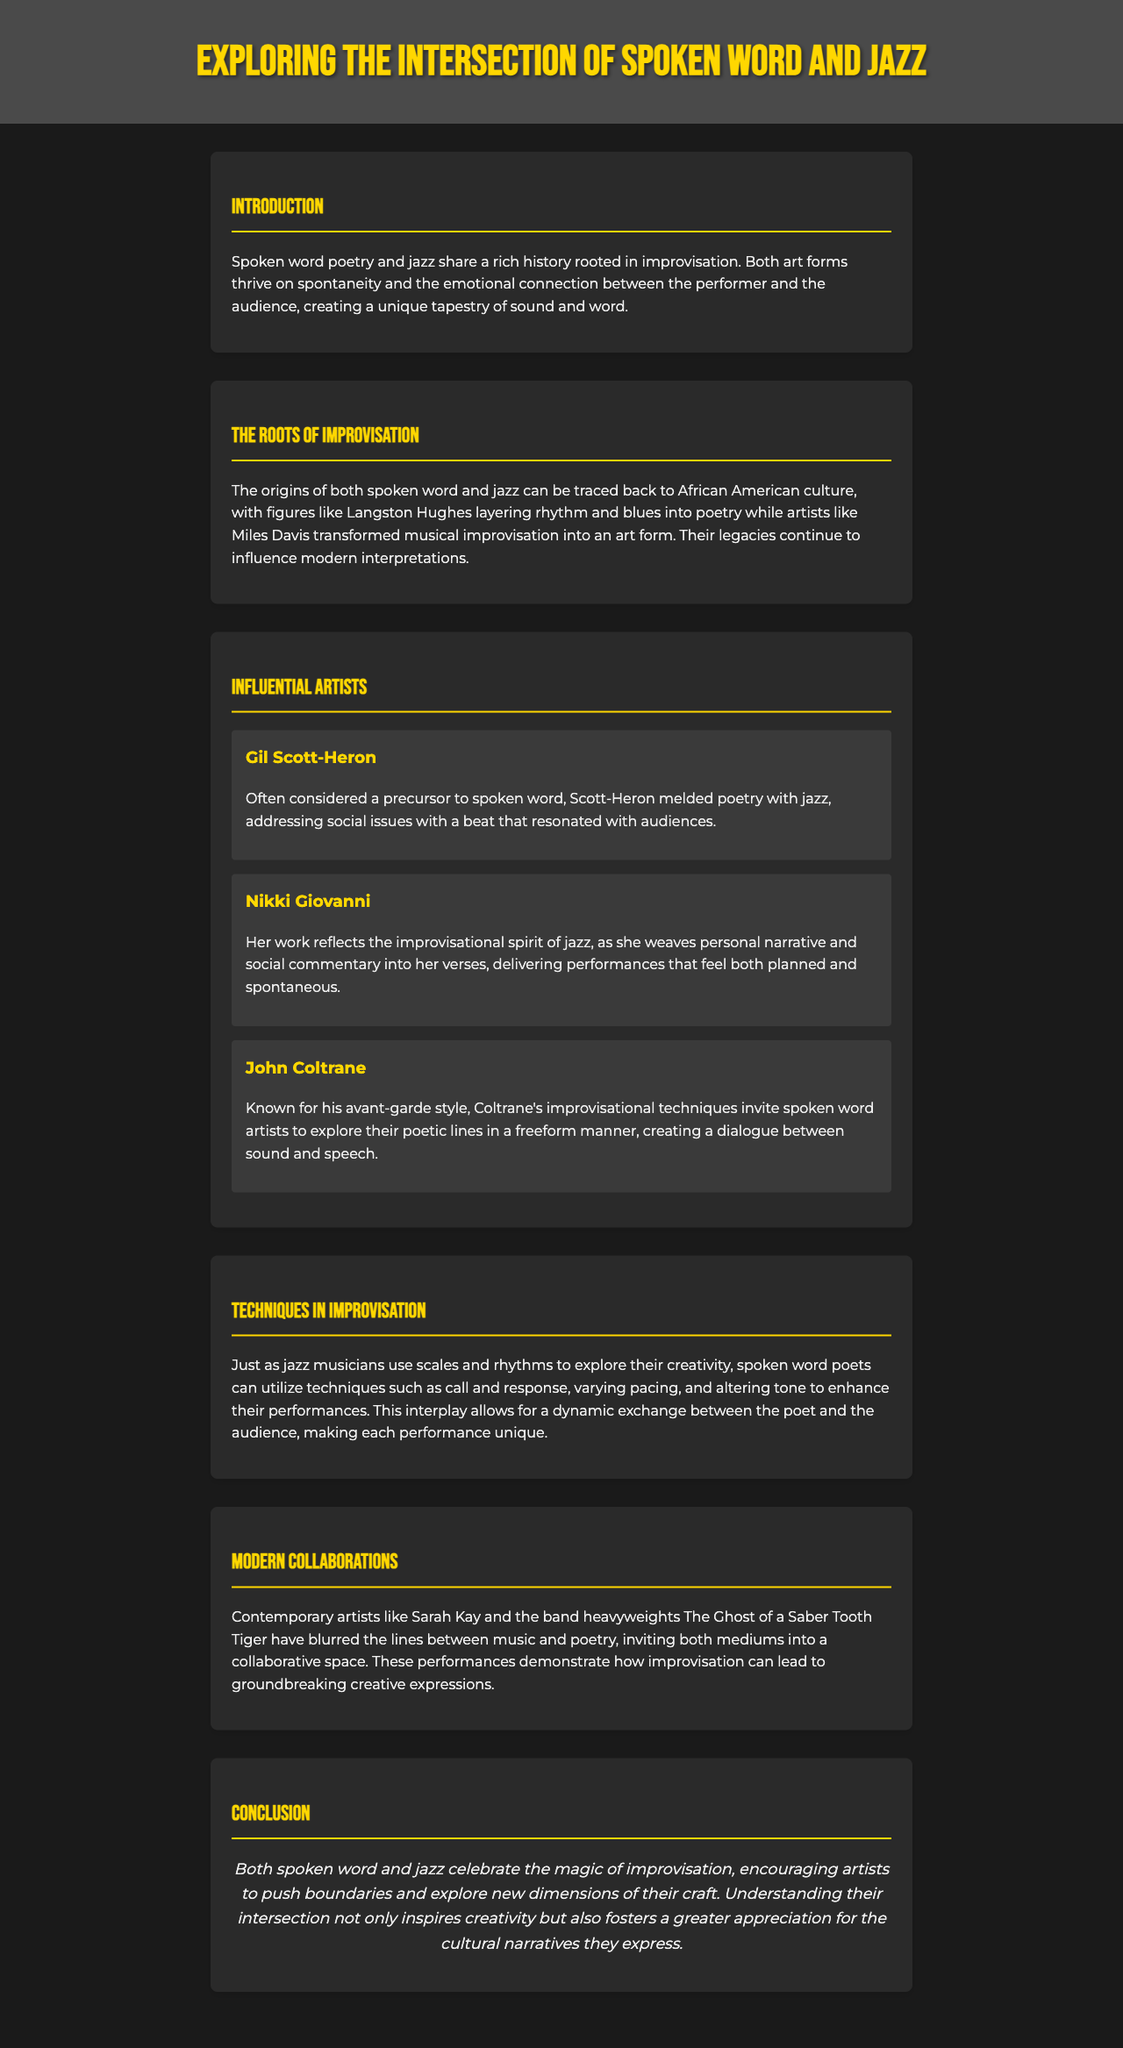What is the focus of the newsletter? The newsletter explores the connection between spoken word poetry and jazz, highlighting improvisation's role in creativity.
Answer: Spoken word and jazz Who is considered a precursor to spoken word? The document mentions Gil Scott-Heron as a significant figure who melded poetry with jazz.
Answer: Gil Scott-Heron Which artist's style invites spoken word artists to explore poetic lines in a freeform manner? John Coltrane's avant-garde style is noted for encouraging exploration among spoken word artists.
Answer: John Coltrane What technique can spoken word poets utilize to enhance their performances? The document lists call and response as a technique for enhancing spoken word performances.
Answer: Call and response Which contemporary artist is mentioned as blurring the lines between music and poetry? Sarah Kay is highlighted as a contemporary artist who collaborates between these two mediums.
Answer: Sarah Kay 